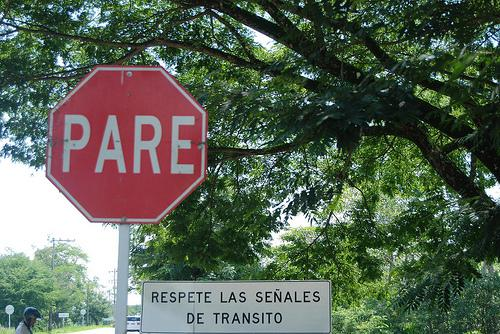Question: where was the picture taken?
Choices:
A. On the path.
B. On the street.
C. On the beach.
D. On the tracks.
Answer with the letter. Answer: B Question: what color are the tree leaves?
Choices:
A. Brown.
B. Red.
C. Green.
D. Yellow.
Answer with the letter. Answer: C Question: what shape is the tallest sign?
Choices:
A. Octagon.
B. Square.
C. Circle.
D. Triangle.
Answer with the letter. Answer: A 